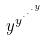<formula> <loc_0><loc_0><loc_500><loc_500>y ^ { y ^ { \cdot ^ { \cdot ^ { \cdot ^ { y } } } } }</formula> 